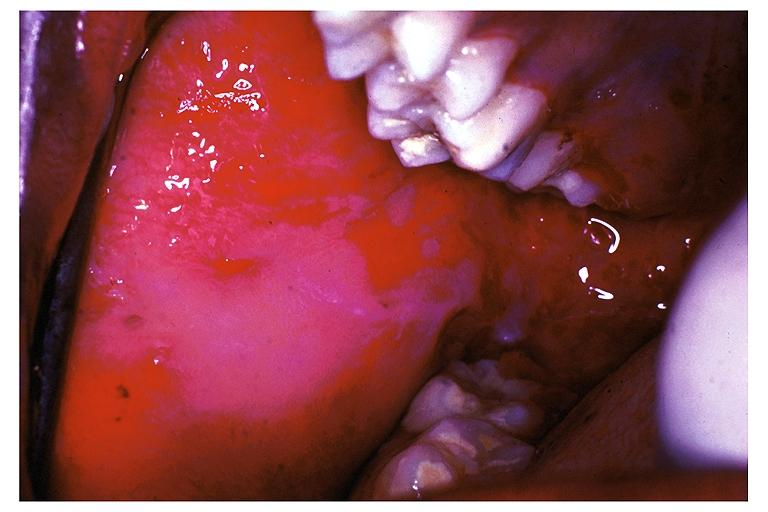what does this image show?
Answer the question using a single word or phrase. Pemphigus vulgaris 